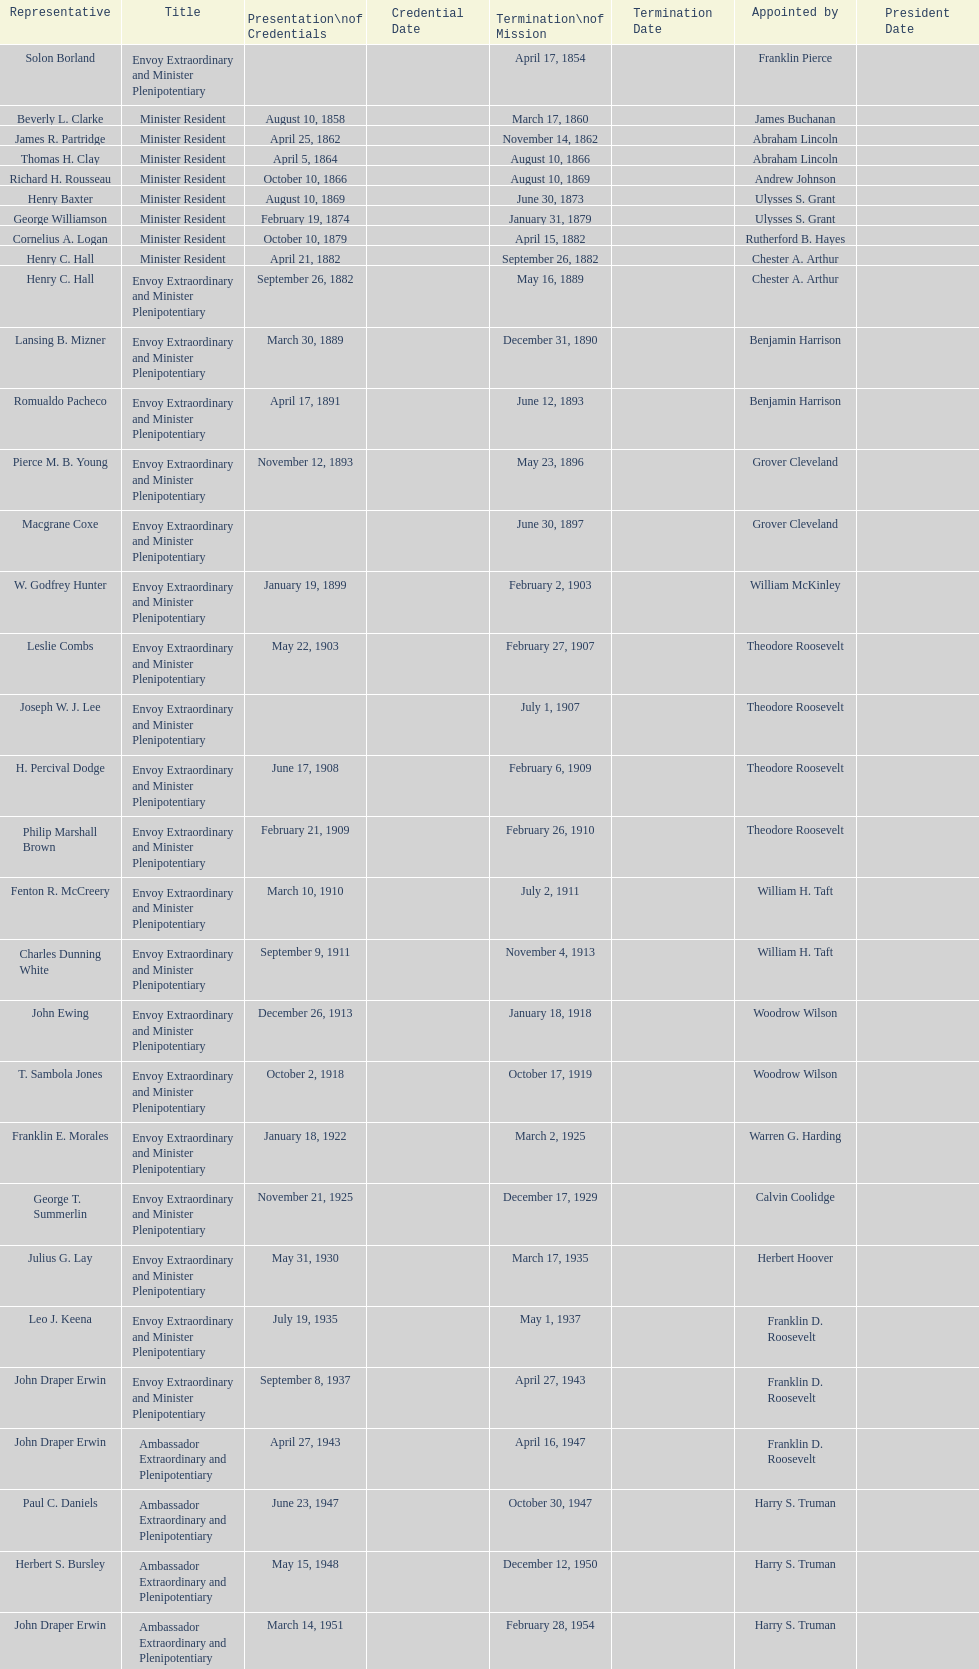Who was the first envoy appointed by woodrow wilson? John Ewing. Could you help me parse every detail presented in this table? {'header': ['Representative', 'Title', 'Presentation\\nof Credentials', 'Credential Date', 'Termination\\nof Mission', 'Termination Date', 'Appointed by', 'President Date'], 'rows': [['Solon Borland', 'Envoy Extraordinary and Minister Plenipotentiary', '', '', 'April 17, 1854', '', 'Franklin Pierce', ''], ['Beverly L. Clarke', 'Minister Resident', 'August 10, 1858', '', 'March 17, 1860', '', 'James Buchanan', ''], ['James R. Partridge', 'Minister Resident', 'April 25, 1862', '', 'November 14, 1862', '', 'Abraham Lincoln', ''], ['Thomas H. Clay', 'Minister Resident', 'April 5, 1864', '', 'August 10, 1866', '', 'Abraham Lincoln', ''], ['Richard H. Rousseau', 'Minister Resident', 'October 10, 1866', '', 'August 10, 1869', '', 'Andrew Johnson', ''], ['Henry Baxter', 'Minister Resident', 'August 10, 1869', '', 'June 30, 1873', '', 'Ulysses S. Grant', ''], ['George Williamson', 'Minister Resident', 'February 19, 1874', '', 'January 31, 1879', '', 'Ulysses S. Grant', ''], ['Cornelius A. Logan', 'Minister Resident', 'October 10, 1879', '', 'April 15, 1882', '', 'Rutherford B. Hayes', ''], ['Henry C. Hall', 'Minister Resident', 'April 21, 1882', '', 'September 26, 1882', '', 'Chester A. Arthur', ''], ['Henry C. Hall', 'Envoy Extraordinary and Minister Plenipotentiary', 'September 26, 1882', '', 'May 16, 1889', '', 'Chester A. Arthur', ''], ['Lansing B. Mizner', 'Envoy Extraordinary and Minister Plenipotentiary', 'March 30, 1889', '', 'December 31, 1890', '', 'Benjamin Harrison', ''], ['Romualdo Pacheco', 'Envoy Extraordinary and Minister Plenipotentiary', 'April 17, 1891', '', 'June 12, 1893', '', 'Benjamin Harrison', ''], ['Pierce M. B. Young', 'Envoy Extraordinary and Minister Plenipotentiary', 'November 12, 1893', '', 'May 23, 1896', '', 'Grover Cleveland', ''], ['Macgrane Coxe', 'Envoy Extraordinary and Minister Plenipotentiary', '', '', 'June 30, 1897', '', 'Grover Cleveland', ''], ['W. Godfrey Hunter', 'Envoy Extraordinary and Minister Plenipotentiary', 'January 19, 1899', '', 'February 2, 1903', '', 'William McKinley', ''], ['Leslie Combs', 'Envoy Extraordinary and Minister Plenipotentiary', 'May 22, 1903', '', 'February 27, 1907', '', 'Theodore Roosevelt', ''], ['Joseph W. J. Lee', 'Envoy Extraordinary and Minister Plenipotentiary', '', '', 'July 1, 1907', '', 'Theodore Roosevelt', ''], ['H. Percival Dodge', 'Envoy Extraordinary and Minister Plenipotentiary', 'June 17, 1908', '', 'February 6, 1909', '', 'Theodore Roosevelt', ''], ['Philip Marshall Brown', 'Envoy Extraordinary and Minister Plenipotentiary', 'February 21, 1909', '', 'February 26, 1910', '', 'Theodore Roosevelt', ''], ['Fenton R. McCreery', 'Envoy Extraordinary and Minister Plenipotentiary', 'March 10, 1910', '', 'July 2, 1911', '', 'William H. Taft', ''], ['Charles Dunning White', 'Envoy Extraordinary and Minister Plenipotentiary', 'September 9, 1911', '', 'November 4, 1913', '', 'William H. Taft', ''], ['John Ewing', 'Envoy Extraordinary and Minister Plenipotentiary', 'December 26, 1913', '', 'January 18, 1918', '', 'Woodrow Wilson', ''], ['T. Sambola Jones', 'Envoy Extraordinary and Minister Plenipotentiary', 'October 2, 1918', '', 'October 17, 1919', '', 'Woodrow Wilson', ''], ['Franklin E. Morales', 'Envoy Extraordinary and Minister Plenipotentiary', 'January 18, 1922', '', 'March 2, 1925', '', 'Warren G. Harding', ''], ['George T. Summerlin', 'Envoy Extraordinary and Minister Plenipotentiary', 'November 21, 1925', '', 'December 17, 1929', '', 'Calvin Coolidge', ''], ['Julius G. Lay', 'Envoy Extraordinary and Minister Plenipotentiary', 'May 31, 1930', '', 'March 17, 1935', '', 'Herbert Hoover', ''], ['Leo J. Keena', 'Envoy Extraordinary and Minister Plenipotentiary', 'July 19, 1935', '', 'May 1, 1937', '', 'Franklin D. Roosevelt', ''], ['John Draper Erwin', 'Envoy Extraordinary and Minister Plenipotentiary', 'September 8, 1937', '', 'April 27, 1943', '', 'Franklin D. Roosevelt', ''], ['John Draper Erwin', 'Ambassador Extraordinary and Plenipotentiary', 'April 27, 1943', '', 'April 16, 1947', '', 'Franklin D. Roosevelt', ''], ['Paul C. Daniels', 'Ambassador Extraordinary and Plenipotentiary', 'June 23, 1947', '', 'October 30, 1947', '', 'Harry S. Truman', ''], ['Herbert S. Bursley', 'Ambassador Extraordinary and Plenipotentiary', 'May 15, 1948', '', 'December 12, 1950', '', 'Harry S. Truman', ''], ['John Draper Erwin', 'Ambassador Extraordinary and Plenipotentiary', 'March 14, 1951', '', 'February 28, 1954', '', 'Harry S. Truman', ''], ['Whiting Willauer', 'Ambassador Extraordinary and Plenipotentiary', 'March 5, 1954', '', 'March 24, 1958', '', 'Dwight D. Eisenhower', ''], ['Robert Newbegin', 'Ambassador Extraordinary and Plenipotentiary', 'April 30, 1958', '', 'August 3, 1960', '', 'Dwight D. Eisenhower', ''], ['Charles R. Burrows', 'Ambassador Extraordinary and Plenipotentiary', 'November 3, 1960', '', 'June 28, 1965', '', 'Dwight D. Eisenhower', ''], ['Joseph J. Jova', 'Ambassador Extraordinary and Plenipotentiary', 'July 12, 1965', '', 'June 21, 1969', '', 'Lyndon B. Johnson', ''], ['Hewson A. Ryan', 'Ambassador Extraordinary and Plenipotentiary', 'November 5, 1969', '', 'May 30, 1973', '', 'Richard Nixon', ''], ['Phillip V. Sanchez', 'Ambassador Extraordinary and Plenipotentiary', 'June 15, 1973', '', 'July 17, 1976', '', 'Richard Nixon', ''], ['Ralph E. Becker', 'Ambassador Extraordinary and Plenipotentiary', 'October 27, 1976', '', 'August 1, 1977', '', 'Gerald Ford', ''], ['Mari-Luci Jaramillo', 'Ambassador Extraordinary and Plenipotentiary', 'October 27, 1977', '', 'September 19, 1980', '', 'Jimmy Carter', ''], ['Jack R. Binns', 'Ambassador Extraordinary and Plenipotentiary', 'October 10, 1980', '', 'October 31, 1981', '', 'Jimmy Carter', ''], ['John D. Negroponte', 'Ambassador Extraordinary and Plenipotentiary', 'November 11, 1981', '', 'May 30, 1985', '', 'Ronald Reagan', ''], ['John Arthur Ferch', 'Ambassador Extraordinary and Plenipotentiary', 'August 22, 1985', '', 'July 9, 1986', '', 'Ronald Reagan', ''], ['Everett Ellis Briggs', 'Ambassador Extraordinary and Plenipotentiary', 'November 4, 1986', '', 'June 15, 1989', '', 'Ronald Reagan', ''], ['Cresencio S. Arcos, Jr.', 'Ambassador Extraordinary and Plenipotentiary', 'January 29, 1990', '', 'July 1, 1993', '', 'George H. W. Bush', ''], ['William Thornton Pryce', 'Ambassador Extraordinary and Plenipotentiary', 'July 21, 1993', '', 'August 15, 1996', '', 'Bill Clinton', ''], ['James F. Creagan', 'Ambassador Extraordinary and Plenipotentiary', 'August 29, 1996', '', 'July 20, 1999', '', 'Bill Clinton', ''], ['Frank Almaguer', 'Ambassador Extraordinary and Plenipotentiary', 'August 25, 1999', '', 'September 5, 2002', '', 'Bill Clinton', ''], ['Larry Leon Palmer', 'Ambassador Extraordinary and Plenipotentiary', 'October 8, 2002', '', 'May 7, 2005', '', 'George W. Bush', ''], ['Charles A. Ford', 'Ambassador Extraordinary and Plenipotentiary', 'November 8, 2005', '', 'ca. April 2008', '', 'George W. Bush', ''], ['Hugo Llorens', 'Ambassador Extraordinary and Plenipotentiary', 'September 19, 2008', '', 'ca. July 2011', '', 'George W. Bush', ''], ['Lisa Kubiske', 'Ambassador Extraordinary and Plenipotentiary', 'July 26, 2011', '', 'Incumbent', '', 'Barack Obama', '']]} 